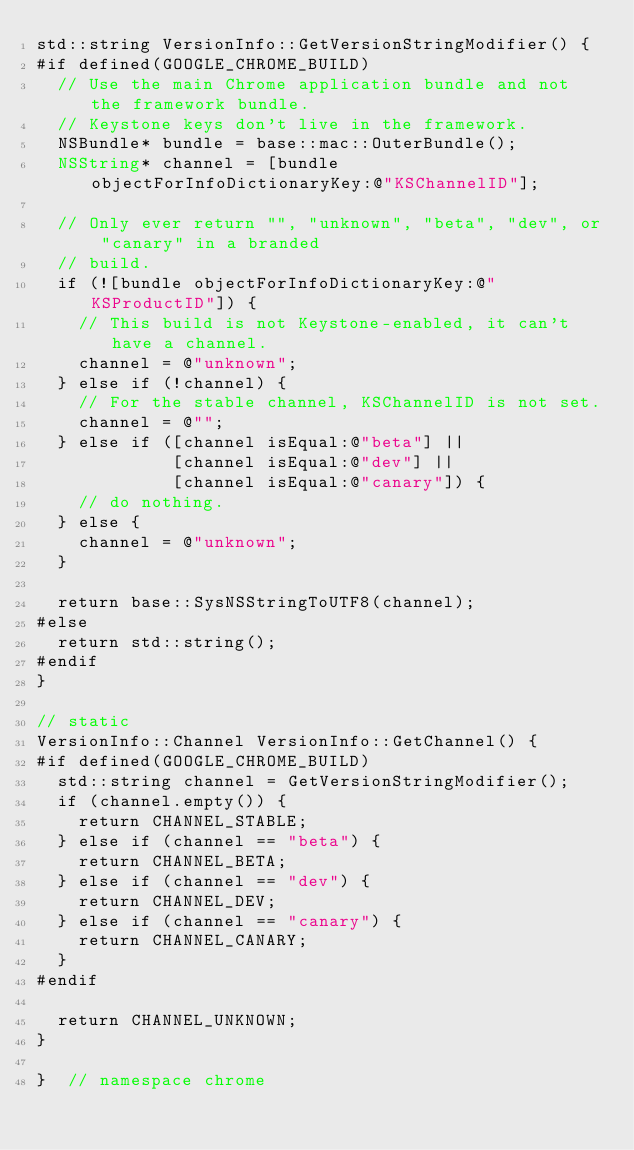Convert code to text. <code><loc_0><loc_0><loc_500><loc_500><_ObjectiveC_>std::string VersionInfo::GetVersionStringModifier() {
#if defined(GOOGLE_CHROME_BUILD)
  // Use the main Chrome application bundle and not the framework bundle.
  // Keystone keys don't live in the framework.
  NSBundle* bundle = base::mac::OuterBundle();
  NSString* channel = [bundle objectForInfoDictionaryKey:@"KSChannelID"];

  // Only ever return "", "unknown", "beta", "dev", or "canary" in a branded
  // build.
  if (![bundle objectForInfoDictionaryKey:@"KSProductID"]) {
    // This build is not Keystone-enabled, it can't have a channel.
    channel = @"unknown";
  } else if (!channel) {
    // For the stable channel, KSChannelID is not set.
    channel = @"";
  } else if ([channel isEqual:@"beta"] ||
             [channel isEqual:@"dev"] ||
             [channel isEqual:@"canary"]) {
    // do nothing.
  } else {
    channel = @"unknown";
  }

  return base::SysNSStringToUTF8(channel);
#else
  return std::string();
#endif
}

// static
VersionInfo::Channel VersionInfo::GetChannel() {
#if defined(GOOGLE_CHROME_BUILD)
  std::string channel = GetVersionStringModifier();
  if (channel.empty()) {
    return CHANNEL_STABLE;
  } else if (channel == "beta") {
    return CHANNEL_BETA;
  } else if (channel == "dev") {
    return CHANNEL_DEV;
  } else if (channel == "canary") {
    return CHANNEL_CANARY;
  }
#endif

  return CHANNEL_UNKNOWN;
}

}  // namespace chrome
</code> 